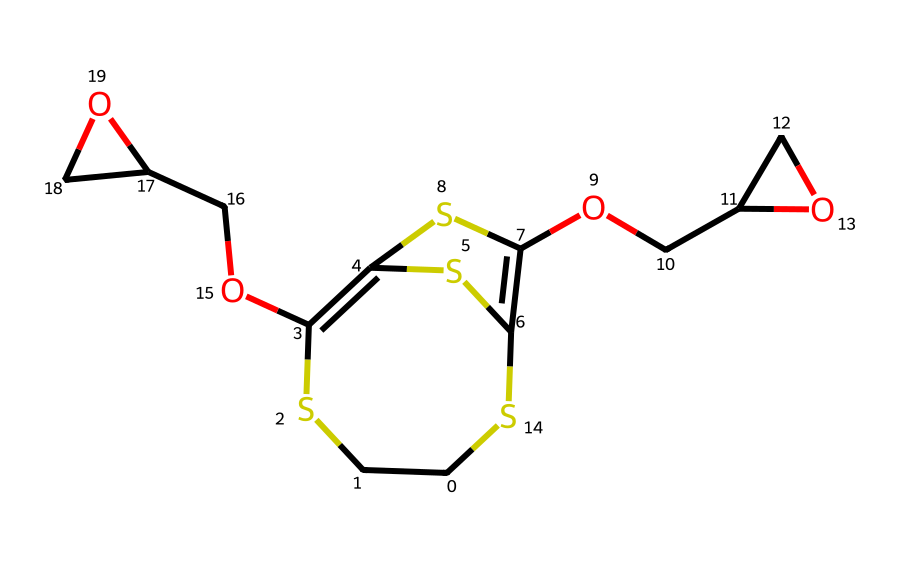What is the total number of carbon atoms in this compound? By analyzing the SMILES representation, we can count the number of carbon (C) atoms. Simply note each 'C' in the structure. Counting reveals that there are eight carbon atoms in total.
Answer: 8 How many oxygen atoms are present in this dye? Looking for 'O' in the SMILES representation helps identify the number of oxygen (O) atoms. There are two occurrences of 'O' in the structure, showing that there are two oxygen atoms.
Answer: 2 Does this polymer dye contain sulfur atoms? We can check for the presence of sulfur (S) atoms by identifying 'S' in the SMILES. Here, we find three occurrences of 'S', indicating that this compound has sulfur atoms.
Answer: 3 What type of polymer is represented by this structure? This compound is a conductive polymer dye, which can be inferred from the presence of conjugated systems within its structure, often utilized for their electronic properties in flexible electronics.
Answer: conductive polymer dye How many rings are there in this molecular structure? In the SMILES notation, we note the presence of 'C1', 'C2', and corresponding closing notations (e.g., 'S1', 'S2'). This indicates that there are cyclic structures. Counting reveals there are two distinct rings.
Answer: 2 What functional group is indicated by 'OCC' in the structure? The 'OCC' part of the SMILES indicates an ether or alcohol functional group. The 'O' (oxygen) is bonded to carbon chains, typical of ether linkages in polymers. Hence, it points to ether functionality.
Answer: ether 